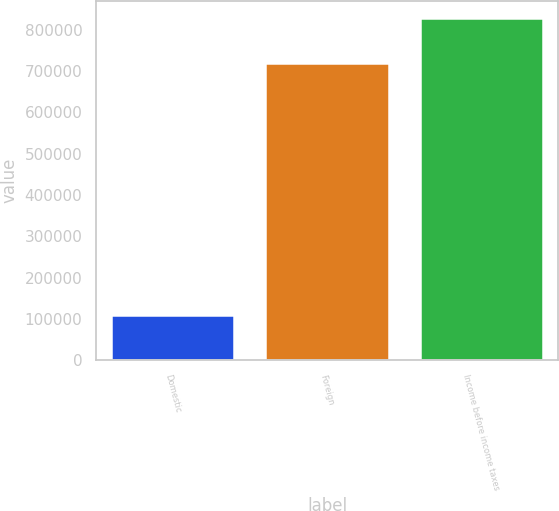Convert chart to OTSL. <chart><loc_0><loc_0><loc_500><loc_500><bar_chart><fcel>Domestic<fcel>Foreign<fcel>Income before income taxes<nl><fcel>109565<fcel>718920<fcel>828485<nl></chart> 